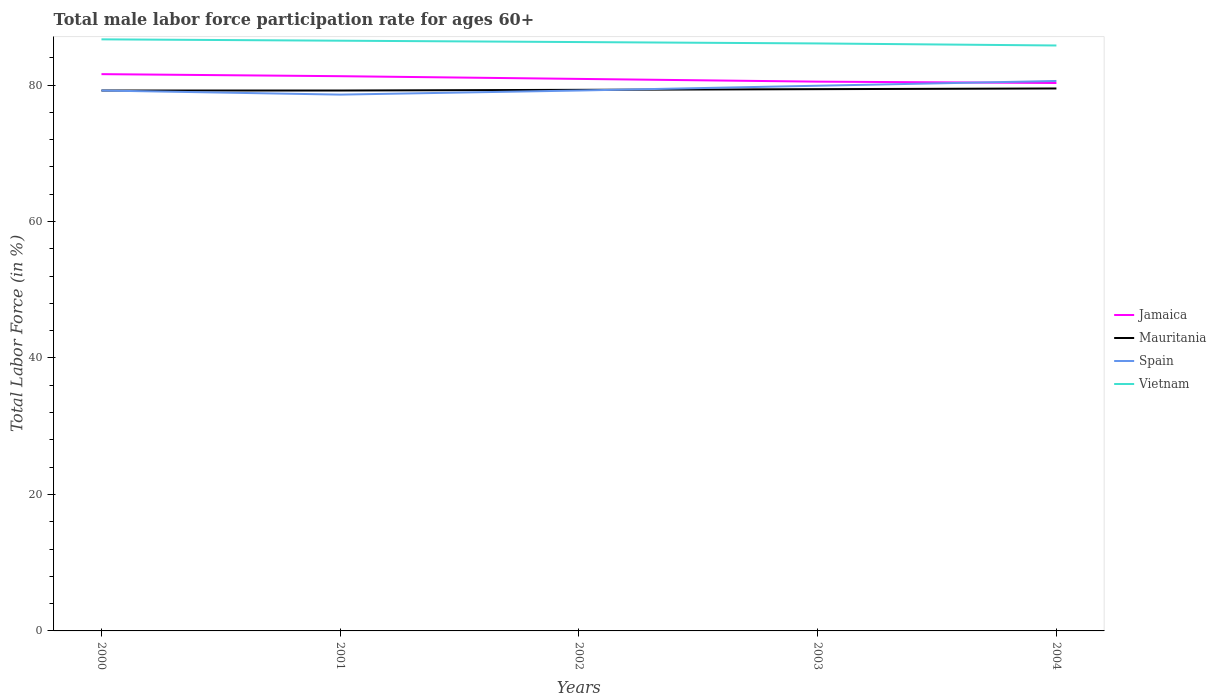Is the number of lines equal to the number of legend labels?
Your answer should be very brief. Yes. Across all years, what is the maximum male labor force participation rate in Jamaica?
Your response must be concise. 80.3. In which year was the male labor force participation rate in Vietnam maximum?
Offer a terse response. 2004. What is the total male labor force participation rate in Jamaica in the graph?
Your response must be concise. 0.6. Is the male labor force participation rate in Spain strictly greater than the male labor force participation rate in Vietnam over the years?
Your response must be concise. Yes. How many lines are there?
Make the answer very short. 4. How many years are there in the graph?
Ensure brevity in your answer.  5. Does the graph contain any zero values?
Ensure brevity in your answer.  No. How are the legend labels stacked?
Offer a very short reply. Vertical. What is the title of the graph?
Your response must be concise. Total male labor force participation rate for ages 60+. What is the label or title of the X-axis?
Keep it short and to the point. Years. What is the Total Labor Force (in %) of Jamaica in 2000?
Make the answer very short. 81.6. What is the Total Labor Force (in %) in Mauritania in 2000?
Ensure brevity in your answer.  79.2. What is the Total Labor Force (in %) of Spain in 2000?
Keep it short and to the point. 79.2. What is the Total Labor Force (in %) in Vietnam in 2000?
Ensure brevity in your answer.  86.7. What is the Total Labor Force (in %) in Jamaica in 2001?
Ensure brevity in your answer.  81.3. What is the Total Labor Force (in %) in Mauritania in 2001?
Make the answer very short. 79.2. What is the Total Labor Force (in %) in Spain in 2001?
Provide a short and direct response. 78.6. What is the Total Labor Force (in %) in Vietnam in 2001?
Your answer should be very brief. 86.5. What is the Total Labor Force (in %) in Jamaica in 2002?
Your response must be concise. 80.9. What is the Total Labor Force (in %) of Mauritania in 2002?
Offer a terse response. 79.3. What is the Total Labor Force (in %) in Spain in 2002?
Provide a short and direct response. 79.2. What is the Total Labor Force (in %) of Vietnam in 2002?
Provide a succinct answer. 86.3. What is the Total Labor Force (in %) of Jamaica in 2003?
Offer a terse response. 80.5. What is the Total Labor Force (in %) in Mauritania in 2003?
Give a very brief answer. 79.4. What is the Total Labor Force (in %) in Spain in 2003?
Keep it short and to the point. 79.9. What is the Total Labor Force (in %) in Vietnam in 2003?
Offer a terse response. 86.1. What is the Total Labor Force (in %) in Jamaica in 2004?
Offer a terse response. 80.3. What is the Total Labor Force (in %) in Mauritania in 2004?
Give a very brief answer. 79.5. What is the Total Labor Force (in %) of Spain in 2004?
Ensure brevity in your answer.  80.6. What is the Total Labor Force (in %) in Vietnam in 2004?
Provide a succinct answer. 85.8. Across all years, what is the maximum Total Labor Force (in %) in Jamaica?
Ensure brevity in your answer.  81.6. Across all years, what is the maximum Total Labor Force (in %) of Mauritania?
Provide a short and direct response. 79.5. Across all years, what is the maximum Total Labor Force (in %) in Spain?
Keep it short and to the point. 80.6. Across all years, what is the maximum Total Labor Force (in %) in Vietnam?
Make the answer very short. 86.7. Across all years, what is the minimum Total Labor Force (in %) of Jamaica?
Your answer should be very brief. 80.3. Across all years, what is the minimum Total Labor Force (in %) in Mauritania?
Offer a terse response. 79.2. Across all years, what is the minimum Total Labor Force (in %) of Spain?
Your answer should be very brief. 78.6. Across all years, what is the minimum Total Labor Force (in %) of Vietnam?
Keep it short and to the point. 85.8. What is the total Total Labor Force (in %) in Jamaica in the graph?
Make the answer very short. 404.6. What is the total Total Labor Force (in %) of Mauritania in the graph?
Keep it short and to the point. 396.6. What is the total Total Labor Force (in %) in Spain in the graph?
Offer a very short reply. 397.5. What is the total Total Labor Force (in %) of Vietnam in the graph?
Your answer should be very brief. 431.4. What is the difference between the Total Labor Force (in %) in Jamaica in 2000 and that in 2001?
Provide a short and direct response. 0.3. What is the difference between the Total Labor Force (in %) of Mauritania in 2000 and that in 2001?
Offer a terse response. 0. What is the difference between the Total Labor Force (in %) of Spain in 2000 and that in 2001?
Your answer should be very brief. 0.6. What is the difference between the Total Labor Force (in %) in Vietnam in 2000 and that in 2001?
Give a very brief answer. 0.2. What is the difference between the Total Labor Force (in %) of Jamaica in 2000 and that in 2002?
Ensure brevity in your answer.  0.7. What is the difference between the Total Labor Force (in %) in Jamaica in 2000 and that in 2003?
Your answer should be compact. 1.1. What is the difference between the Total Labor Force (in %) of Mauritania in 2000 and that in 2003?
Provide a succinct answer. -0.2. What is the difference between the Total Labor Force (in %) of Vietnam in 2000 and that in 2003?
Your response must be concise. 0.6. What is the difference between the Total Labor Force (in %) in Jamaica in 2000 and that in 2004?
Your answer should be compact. 1.3. What is the difference between the Total Labor Force (in %) in Mauritania in 2000 and that in 2004?
Ensure brevity in your answer.  -0.3. What is the difference between the Total Labor Force (in %) of Mauritania in 2001 and that in 2002?
Provide a short and direct response. -0.1. What is the difference between the Total Labor Force (in %) of Vietnam in 2001 and that in 2002?
Offer a very short reply. 0.2. What is the difference between the Total Labor Force (in %) of Jamaica in 2001 and that in 2004?
Your response must be concise. 1. What is the difference between the Total Labor Force (in %) in Mauritania in 2001 and that in 2004?
Your answer should be very brief. -0.3. What is the difference between the Total Labor Force (in %) of Jamaica in 2002 and that in 2003?
Provide a succinct answer. 0.4. What is the difference between the Total Labor Force (in %) in Spain in 2002 and that in 2003?
Ensure brevity in your answer.  -0.7. What is the difference between the Total Labor Force (in %) of Spain in 2002 and that in 2004?
Your answer should be compact. -1.4. What is the difference between the Total Labor Force (in %) of Mauritania in 2003 and that in 2004?
Provide a short and direct response. -0.1. What is the difference between the Total Labor Force (in %) in Spain in 2003 and that in 2004?
Your answer should be very brief. -0.7. What is the difference between the Total Labor Force (in %) in Jamaica in 2000 and the Total Labor Force (in %) in Vietnam in 2001?
Your response must be concise. -4.9. What is the difference between the Total Labor Force (in %) in Mauritania in 2000 and the Total Labor Force (in %) in Spain in 2001?
Your response must be concise. 0.6. What is the difference between the Total Labor Force (in %) in Mauritania in 2000 and the Total Labor Force (in %) in Vietnam in 2001?
Keep it short and to the point. -7.3. What is the difference between the Total Labor Force (in %) of Spain in 2000 and the Total Labor Force (in %) of Vietnam in 2001?
Offer a very short reply. -7.3. What is the difference between the Total Labor Force (in %) in Jamaica in 2000 and the Total Labor Force (in %) in Vietnam in 2002?
Offer a very short reply. -4.7. What is the difference between the Total Labor Force (in %) of Mauritania in 2000 and the Total Labor Force (in %) of Vietnam in 2002?
Provide a short and direct response. -7.1. What is the difference between the Total Labor Force (in %) in Spain in 2000 and the Total Labor Force (in %) in Vietnam in 2002?
Your answer should be very brief. -7.1. What is the difference between the Total Labor Force (in %) of Jamaica in 2000 and the Total Labor Force (in %) of Mauritania in 2003?
Your answer should be very brief. 2.2. What is the difference between the Total Labor Force (in %) in Mauritania in 2000 and the Total Labor Force (in %) in Spain in 2003?
Your response must be concise. -0.7. What is the difference between the Total Labor Force (in %) of Spain in 2000 and the Total Labor Force (in %) of Vietnam in 2003?
Your response must be concise. -6.9. What is the difference between the Total Labor Force (in %) of Jamaica in 2000 and the Total Labor Force (in %) of Spain in 2004?
Keep it short and to the point. 1. What is the difference between the Total Labor Force (in %) in Jamaica in 2000 and the Total Labor Force (in %) in Vietnam in 2004?
Ensure brevity in your answer.  -4.2. What is the difference between the Total Labor Force (in %) of Mauritania in 2000 and the Total Labor Force (in %) of Spain in 2004?
Your answer should be very brief. -1.4. What is the difference between the Total Labor Force (in %) in Mauritania in 2000 and the Total Labor Force (in %) in Vietnam in 2004?
Provide a succinct answer. -6.6. What is the difference between the Total Labor Force (in %) of Spain in 2000 and the Total Labor Force (in %) of Vietnam in 2004?
Offer a very short reply. -6.6. What is the difference between the Total Labor Force (in %) of Jamaica in 2001 and the Total Labor Force (in %) of Spain in 2002?
Provide a succinct answer. 2.1. What is the difference between the Total Labor Force (in %) in Mauritania in 2001 and the Total Labor Force (in %) in Vietnam in 2002?
Make the answer very short. -7.1. What is the difference between the Total Labor Force (in %) in Jamaica in 2001 and the Total Labor Force (in %) in Mauritania in 2003?
Offer a very short reply. 1.9. What is the difference between the Total Labor Force (in %) in Jamaica in 2001 and the Total Labor Force (in %) in Vietnam in 2003?
Provide a succinct answer. -4.8. What is the difference between the Total Labor Force (in %) of Mauritania in 2001 and the Total Labor Force (in %) of Vietnam in 2003?
Offer a terse response. -6.9. What is the difference between the Total Labor Force (in %) of Spain in 2001 and the Total Labor Force (in %) of Vietnam in 2003?
Provide a succinct answer. -7.5. What is the difference between the Total Labor Force (in %) of Jamaica in 2001 and the Total Labor Force (in %) of Mauritania in 2004?
Your answer should be very brief. 1.8. What is the difference between the Total Labor Force (in %) of Mauritania in 2001 and the Total Labor Force (in %) of Spain in 2004?
Offer a very short reply. -1.4. What is the difference between the Total Labor Force (in %) in Mauritania in 2001 and the Total Labor Force (in %) in Vietnam in 2004?
Give a very brief answer. -6.6. What is the difference between the Total Labor Force (in %) in Spain in 2001 and the Total Labor Force (in %) in Vietnam in 2004?
Offer a very short reply. -7.2. What is the difference between the Total Labor Force (in %) in Jamaica in 2002 and the Total Labor Force (in %) in Spain in 2003?
Offer a very short reply. 1. What is the difference between the Total Labor Force (in %) of Jamaica in 2002 and the Total Labor Force (in %) of Vietnam in 2003?
Your response must be concise. -5.2. What is the difference between the Total Labor Force (in %) of Mauritania in 2002 and the Total Labor Force (in %) of Vietnam in 2003?
Give a very brief answer. -6.8. What is the difference between the Total Labor Force (in %) of Jamaica in 2002 and the Total Labor Force (in %) of Spain in 2004?
Provide a succinct answer. 0.3. What is the difference between the Total Labor Force (in %) of Jamaica in 2002 and the Total Labor Force (in %) of Vietnam in 2004?
Keep it short and to the point. -4.9. What is the difference between the Total Labor Force (in %) of Mauritania in 2002 and the Total Labor Force (in %) of Vietnam in 2004?
Provide a succinct answer. -6.5. What is the difference between the Total Labor Force (in %) in Spain in 2002 and the Total Labor Force (in %) in Vietnam in 2004?
Your answer should be very brief. -6.6. What is the difference between the Total Labor Force (in %) of Mauritania in 2003 and the Total Labor Force (in %) of Spain in 2004?
Give a very brief answer. -1.2. What is the difference between the Total Labor Force (in %) in Mauritania in 2003 and the Total Labor Force (in %) in Vietnam in 2004?
Offer a terse response. -6.4. What is the difference between the Total Labor Force (in %) of Spain in 2003 and the Total Labor Force (in %) of Vietnam in 2004?
Provide a short and direct response. -5.9. What is the average Total Labor Force (in %) in Jamaica per year?
Your answer should be compact. 80.92. What is the average Total Labor Force (in %) in Mauritania per year?
Make the answer very short. 79.32. What is the average Total Labor Force (in %) in Spain per year?
Make the answer very short. 79.5. What is the average Total Labor Force (in %) in Vietnam per year?
Offer a terse response. 86.28. In the year 2000, what is the difference between the Total Labor Force (in %) of Mauritania and Total Labor Force (in %) of Vietnam?
Keep it short and to the point. -7.5. In the year 2001, what is the difference between the Total Labor Force (in %) of Jamaica and Total Labor Force (in %) of Vietnam?
Offer a terse response. -5.2. In the year 2001, what is the difference between the Total Labor Force (in %) in Mauritania and Total Labor Force (in %) in Spain?
Keep it short and to the point. 0.6. In the year 2001, what is the difference between the Total Labor Force (in %) of Mauritania and Total Labor Force (in %) of Vietnam?
Your response must be concise. -7.3. In the year 2001, what is the difference between the Total Labor Force (in %) in Spain and Total Labor Force (in %) in Vietnam?
Offer a terse response. -7.9. In the year 2002, what is the difference between the Total Labor Force (in %) of Jamaica and Total Labor Force (in %) of Vietnam?
Offer a very short reply. -5.4. In the year 2002, what is the difference between the Total Labor Force (in %) of Mauritania and Total Labor Force (in %) of Vietnam?
Keep it short and to the point. -7. In the year 2002, what is the difference between the Total Labor Force (in %) in Spain and Total Labor Force (in %) in Vietnam?
Your answer should be very brief. -7.1. In the year 2004, what is the difference between the Total Labor Force (in %) of Jamaica and Total Labor Force (in %) of Mauritania?
Offer a terse response. 0.8. In the year 2004, what is the difference between the Total Labor Force (in %) of Mauritania and Total Labor Force (in %) of Spain?
Your answer should be compact. -1.1. In the year 2004, what is the difference between the Total Labor Force (in %) in Spain and Total Labor Force (in %) in Vietnam?
Ensure brevity in your answer.  -5.2. What is the ratio of the Total Labor Force (in %) in Jamaica in 2000 to that in 2001?
Offer a very short reply. 1. What is the ratio of the Total Labor Force (in %) in Mauritania in 2000 to that in 2001?
Make the answer very short. 1. What is the ratio of the Total Labor Force (in %) in Spain in 2000 to that in 2001?
Offer a very short reply. 1.01. What is the ratio of the Total Labor Force (in %) of Jamaica in 2000 to that in 2002?
Provide a succinct answer. 1.01. What is the ratio of the Total Labor Force (in %) of Jamaica in 2000 to that in 2003?
Offer a very short reply. 1.01. What is the ratio of the Total Labor Force (in %) of Mauritania in 2000 to that in 2003?
Offer a terse response. 1. What is the ratio of the Total Labor Force (in %) in Spain in 2000 to that in 2003?
Provide a short and direct response. 0.99. What is the ratio of the Total Labor Force (in %) in Jamaica in 2000 to that in 2004?
Offer a terse response. 1.02. What is the ratio of the Total Labor Force (in %) in Mauritania in 2000 to that in 2004?
Your answer should be compact. 1. What is the ratio of the Total Labor Force (in %) of Spain in 2000 to that in 2004?
Keep it short and to the point. 0.98. What is the ratio of the Total Labor Force (in %) of Vietnam in 2000 to that in 2004?
Give a very brief answer. 1.01. What is the ratio of the Total Labor Force (in %) in Jamaica in 2001 to that in 2002?
Your response must be concise. 1. What is the ratio of the Total Labor Force (in %) of Mauritania in 2001 to that in 2002?
Provide a succinct answer. 1. What is the ratio of the Total Labor Force (in %) in Jamaica in 2001 to that in 2003?
Offer a terse response. 1.01. What is the ratio of the Total Labor Force (in %) in Mauritania in 2001 to that in 2003?
Give a very brief answer. 1. What is the ratio of the Total Labor Force (in %) in Spain in 2001 to that in 2003?
Give a very brief answer. 0.98. What is the ratio of the Total Labor Force (in %) of Jamaica in 2001 to that in 2004?
Ensure brevity in your answer.  1.01. What is the ratio of the Total Labor Force (in %) of Mauritania in 2001 to that in 2004?
Your response must be concise. 1. What is the ratio of the Total Labor Force (in %) of Spain in 2001 to that in 2004?
Provide a short and direct response. 0.98. What is the ratio of the Total Labor Force (in %) of Vietnam in 2001 to that in 2004?
Offer a terse response. 1.01. What is the ratio of the Total Labor Force (in %) of Jamaica in 2002 to that in 2003?
Ensure brevity in your answer.  1. What is the ratio of the Total Labor Force (in %) in Mauritania in 2002 to that in 2003?
Your response must be concise. 1. What is the ratio of the Total Labor Force (in %) in Spain in 2002 to that in 2003?
Your answer should be very brief. 0.99. What is the ratio of the Total Labor Force (in %) in Vietnam in 2002 to that in 2003?
Your response must be concise. 1. What is the ratio of the Total Labor Force (in %) of Jamaica in 2002 to that in 2004?
Offer a terse response. 1.01. What is the ratio of the Total Labor Force (in %) of Mauritania in 2002 to that in 2004?
Give a very brief answer. 1. What is the ratio of the Total Labor Force (in %) in Spain in 2002 to that in 2004?
Provide a succinct answer. 0.98. What is the ratio of the Total Labor Force (in %) of Mauritania in 2003 to that in 2004?
Make the answer very short. 1. What is the ratio of the Total Labor Force (in %) in Spain in 2003 to that in 2004?
Your answer should be very brief. 0.99. What is the difference between the highest and the second highest Total Labor Force (in %) in Mauritania?
Your answer should be compact. 0.1. What is the difference between the highest and the second highest Total Labor Force (in %) in Spain?
Give a very brief answer. 0.7. What is the difference between the highest and the lowest Total Labor Force (in %) in Jamaica?
Make the answer very short. 1.3. What is the difference between the highest and the lowest Total Labor Force (in %) of Mauritania?
Provide a succinct answer. 0.3. What is the difference between the highest and the lowest Total Labor Force (in %) of Spain?
Ensure brevity in your answer.  2. What is the difference between the highest and the lowest Total Labor Force (in %) in Vietnam?
Provide a succinct answer. 0.9. 